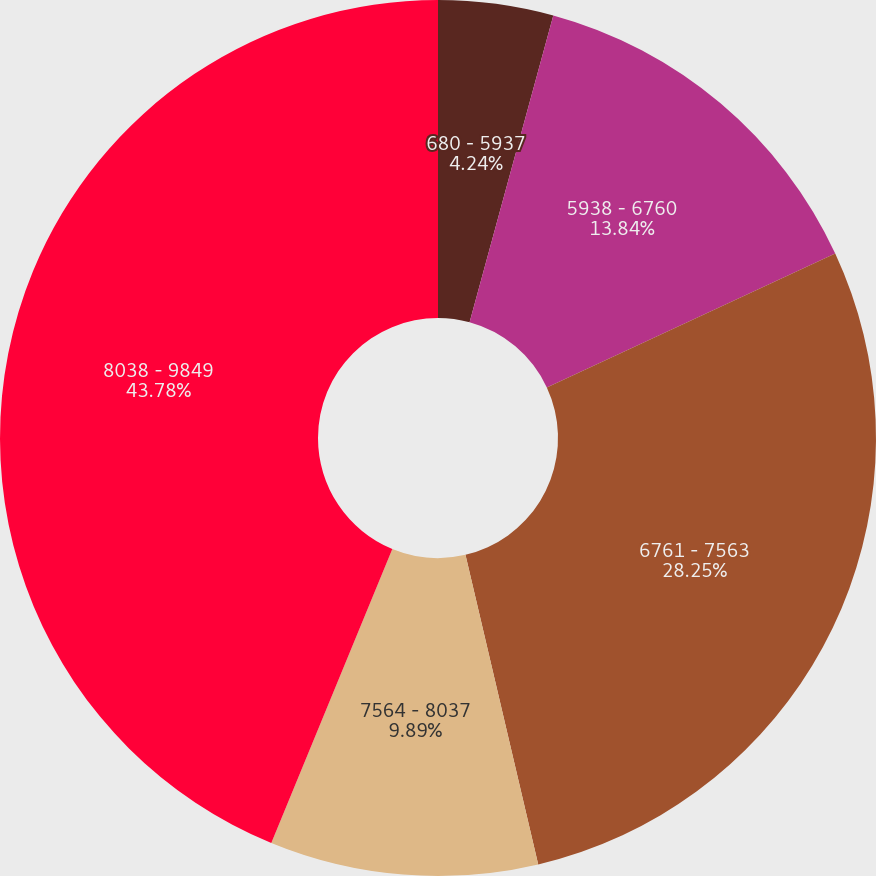Convert chart to OTSL. <chart><loc_0><loc_0><loc_500><loc_500><pie_chart><fcel>680 - 5937<fcel>5938 - 6760<fcel>6761 - 7563<fcel>7564 - 8037<fcel>8038 - 9849<nl><fcel>4.24%<fcel>13.84%<fcel>28.25%<fcel>9.89%<fcel>43.79%<nl></chart> 